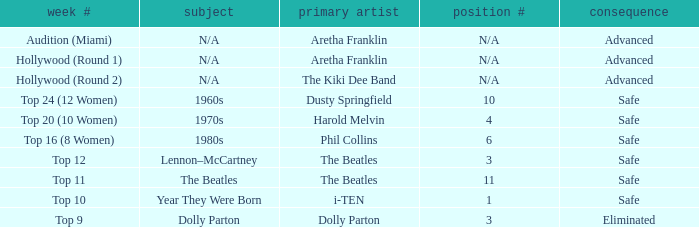What is the week number with Phil Collins as the original artist? Top 16 (8 Women). 